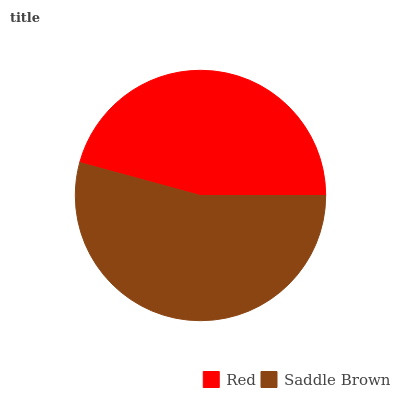Is Red the minimum?
Answer yes or no. Yes. Is Saddle Brown the maximum?
Answer yes or no. Yes. Is Saddle Brown the minimum?
Answer yes or no. No. Is Saddle Brown greater than Red?
Answer yes or no. Yes. Is Red less than Saddle Brown?
Answer yes or no. Yes. Is Red greater than Saddle Brown?
Answer yes or no. No. Is Saddle Brown less than Red?
Answer yes or no. No. Is Saddle Brown the high median?
Answer yes or no. Yes. Is Red the low median?
Answer yes or no. Yes. Is Red the high median?
Answer yes or no. No. Is Saddle Brown the low median?
Answer yes or no. No. 